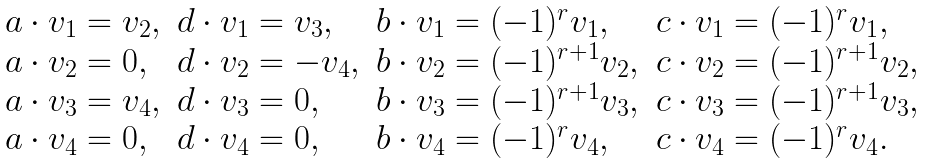Convert formula to latex. <formula><loc_0><loc_0><loc_500><loc_500>\begin{array} { l l l l } a \cdot v _ { 1 } = v _ { 2 } , & d \cdot v _ { 1 } = v _ { 3 } , & b \cdot v _ { 1 } = ( - 1 ) ^ { r } v _ { 1 } , & c \cdot v _ { 1 } = ( - 1 ) ^ { r } v _ { 1 } , \\ a \cdot v _ { 2 } = 0 , & d \cdot v _ { 2 } = - v _ { 4 } , & b \cdot v _ { 2 } = ( - 1 ) ^ { r + 1 } v _ { 2 } , & c \cdot v _ { 2 } = ( - 1 ) ^ { r + 1 } v _ { 2 } , \\ a \cdot v _ { 3 } = v _ { 4 } , & d \cdot v _ { 3 } = 0 , & b \cdot v _ { 3 } = ( - 1 ) ^ { r + 1 } v _ { 3 } , & c \cdot v _ { 3 } = ( - 1 ) ^ { r + 1 } v _ { 3 } , \\ a \cdot v _ { 4 } = 0 , & d \cdot v _ { 4 } = 0 , & b \cdot v _ { 4 } = ( - 1 ) ^ { r } v _ { 4 } , & c \cdot v _ { 4 } = ( - 1 ) ^ { r } v _ { 4 } . \end{array}</formula> 